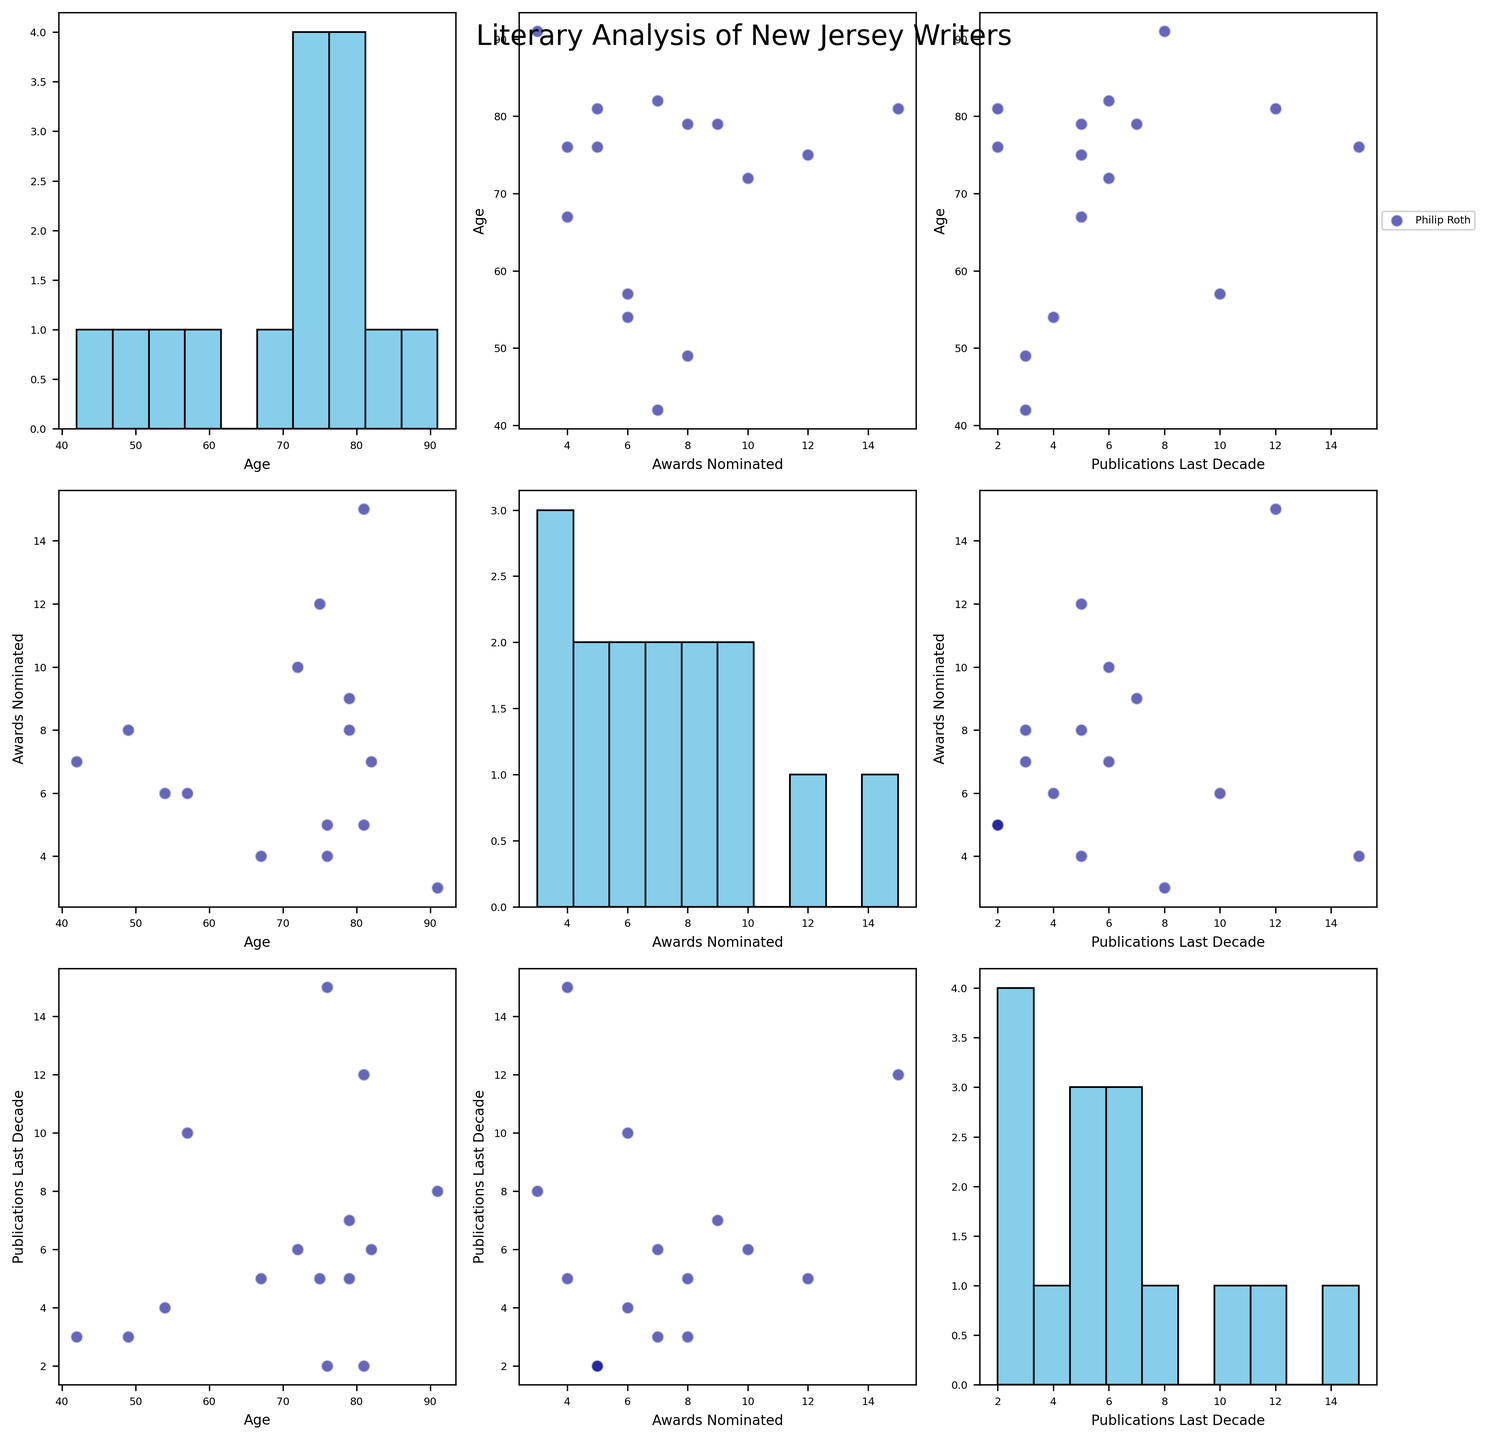What's the highest number of literary awards nominated for any author? By checking the "Awards Nominated" histogram in the scatterplot matrix, we can see the highest bin extending up to 15. Joyce Carol Oates is shown as the author with 15 awards nominations.
Answer: 15 Which age group has the most publications in the last decade? Looking at the scatterplot of "Publications Last Decade" vs. "Age," we can identify the age groups with the highest publication frequencies. The highest data points are near age 76 and 81 (Janet Evanovich and Joyce Carol Oates).
Answer: 76 and 81 How does the number of publications in the last decade relate to the number of awards nominations? To determine this, examine the scatterplot of "Publications Last Decade" vs. "Awards Nominated". Observing trends, we see that authors with higher numbers of publications tend to have high nominations (e.g., Joyce Carol Oates and Janet Evanovich).
Answer: More publications often correlate with more nominations Which author has received the second highest number of awards nominations, and how many publications do they have in the last decade? Reviewing the "Awards Nominated" histogram and identifying the second highest point after 15, we see Philip Roth with 12 nominations. In the scatterplot matrix, his publications mark is 5 in the corresponding plot.
Answer: Philip Roth, 5 Are older authors generally more nominated for awards? Examining the scatterplot "Awards Nominated" vs. "Age", there appears to be a weak trend where older authors have higher awards nominations, as several points higher in age also have higher nominations. However, it's not a strict correlation.
Answer: Generally, yes What's the median age of the authors represented in this scatterplot matrix? By observing the "Age" histogram, which is ordered by increments of around 5 years, we can count the bars and notice that the central data point clusters near age 75.
Answer: Approximately 75 Is there a noticeable concentration of authors in a specific range of publication frequency? From the "Publications Last Decade" histogram, there is a noticeable concentration around the 4-6 publications range. This mode during these intervals indicates a common publishing rate.
Answer: Yes, in the 4-6 range How does Joyce Carol Oates compare to Junot Díaz in terms of both age and awards nominated? Comparing their positions in the scatterplot "Age" vs. "Awards Nominated," Joyce Carol Oates is 81 with 15 nominations, while Junot Díaz is 49 with 8 nominations. Oates is older and has more nominations.
Answer: Oates is older and has more nominations What can you infer about the relationship between age and publications in the last decade? Evaluating the scatterplot "Age" vs. "Publications Last Decade," there doesn’t seem to be a strong relationship as the points are quite dispersed, indicating no clear trend between age and publication count.
Answer: No strong relationship 